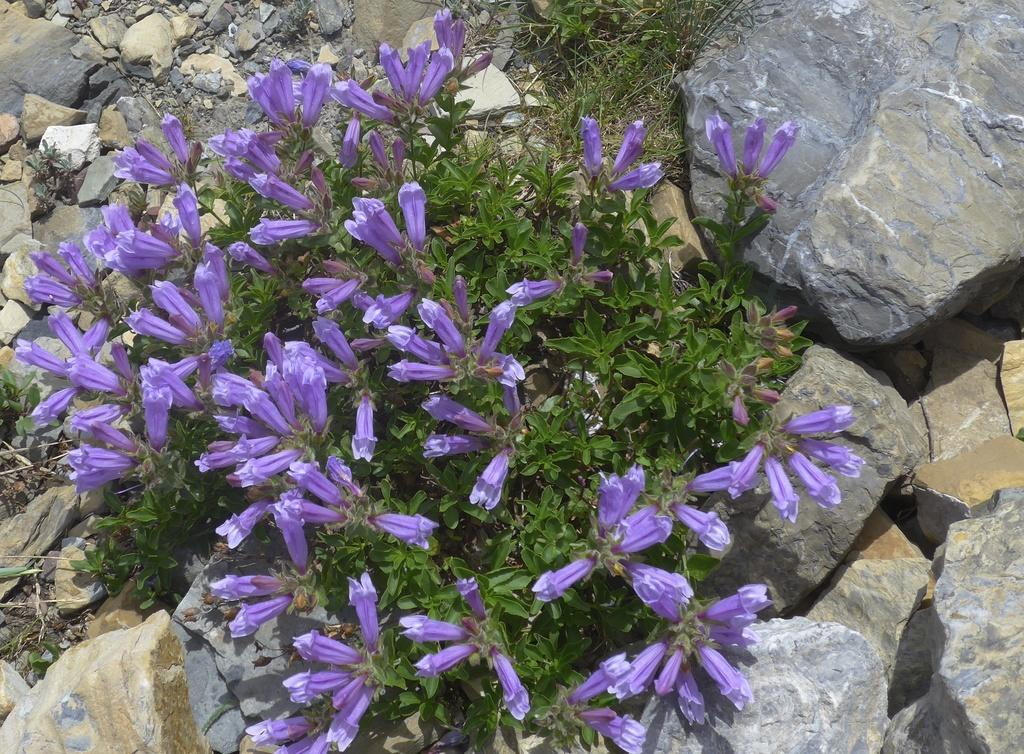What type of plants can be seen in the image? There are plants with flowers in the image. What color are the flowers on the plants? The flowers are in a purple color. What can be seen in the background of the image? There are rocks visible in the background of the image. What type of skin condition can be seen on the flowers in the image? There is no skin condition present on the flowers in the image, as flowers do not have skin. 